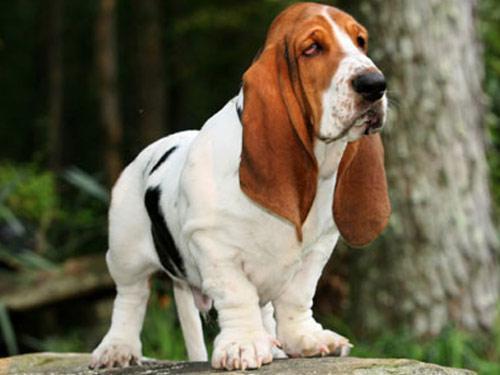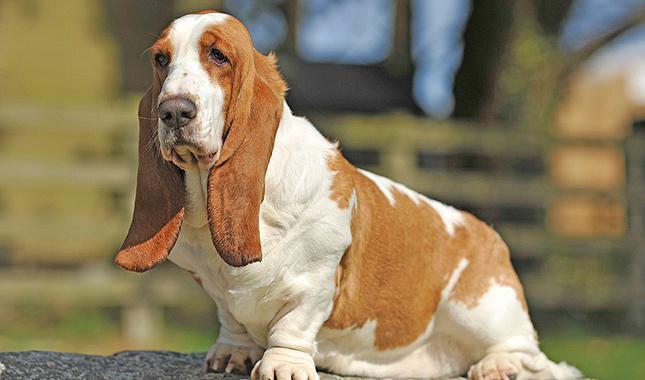The first image is the image on the left, the second image is the image on the right. Evaluate the accuracy of this statement regarding the images: "There are two dogs total on both images.". Is it true? Answer yes or no. Yes. 